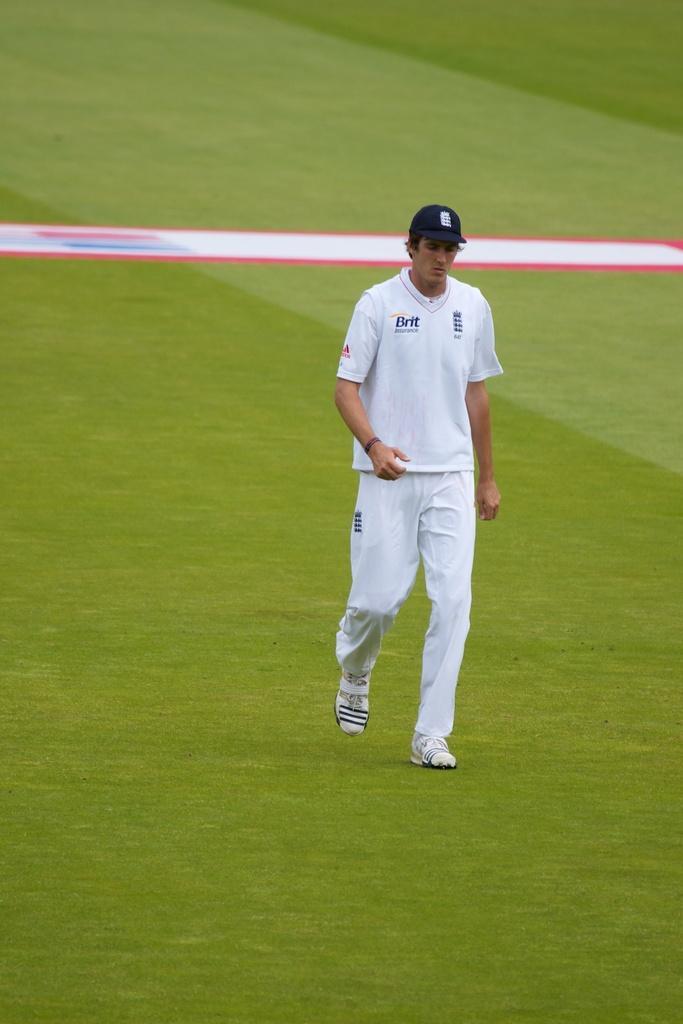In one or two sentences, can you explain what this image depicts? In this image there is a person with a hat is standing on the grass. 